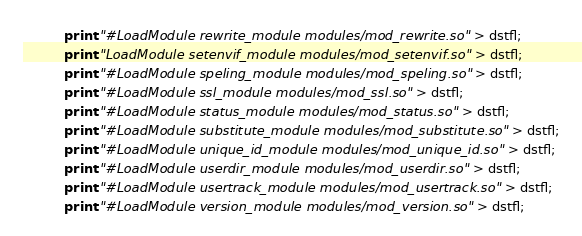<code> <loc_0><loc_0><loc_500><loc_500><_Awk_>          print "#LoadModule rewrite_module modules/mod_rewrite.so" > dstfl;
          print "LoadModule setenvif_module modules/mod_setenvif.so" > dstfl;
          print "#LoadModule speling_module modules/mod_speling.so" > dstfl;
          print "#LoadModule ssl_module modules/mod_ssl.so" > dstfl;
          print "#LoadModule status_module modules/mod_status.so" > dstfl;
          print "#LoadModule substitute_module modules/mod_substitute.so" > dstfl;
          print "#LoadModule unique_id_module modules/mod_unique_id.so" > dstfl;
          print "#LoadModule userdir_module modules/mod_userdir.so" > dstfl;
          print "#LoadModule usertrack_module modules/mod_usertrack.so" > dstfl;
          print "#LoadModule version_module modules/mod_version.so" > dstfl;</code> 